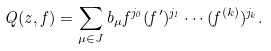<formula> <loc_0><loc_0><loc_500><loc_500>Q ( z , f ) = \sum _ { \mu \in J } b _ { \mu } f ^ { j _ { 0 } } ( f ^ { \prime } ) ^ { j _ { 1 } } \cdots ( f ^ { ( k ) } ) ^ { j _ { k } } .</formula> 